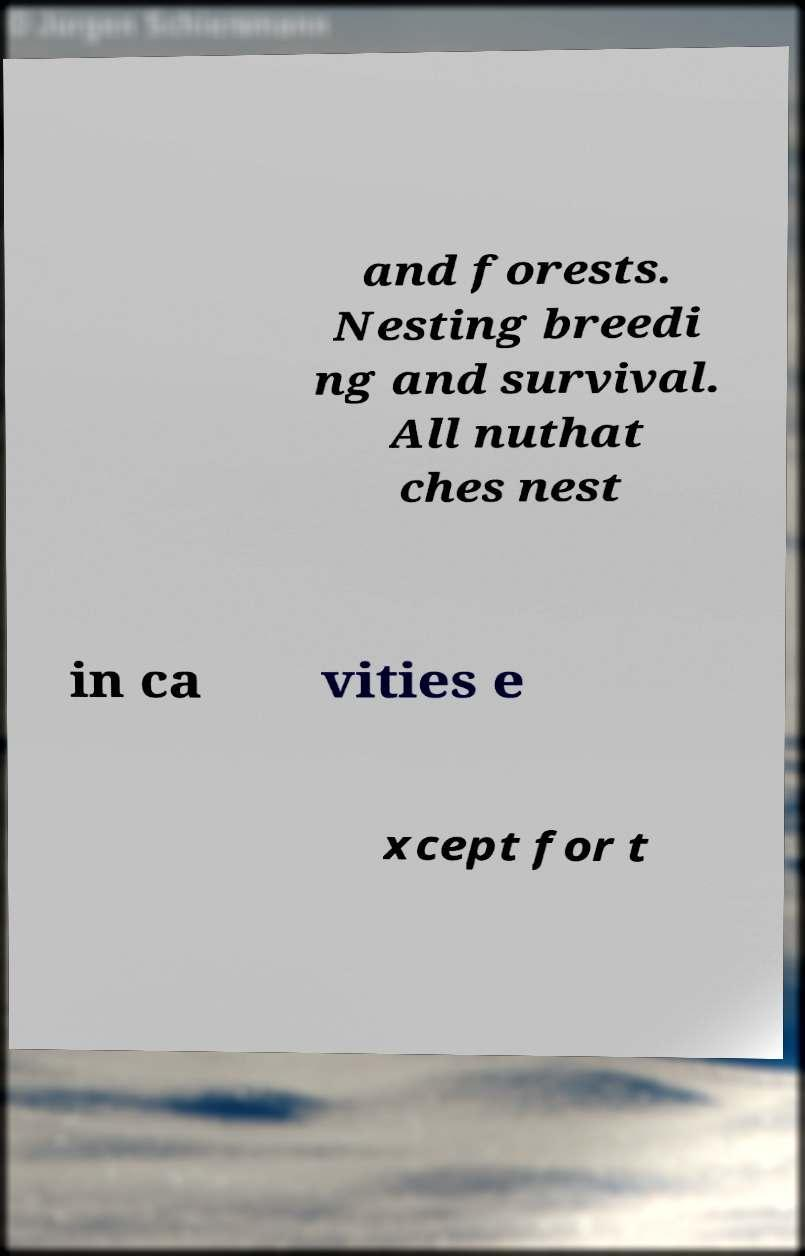I need the written content from this picture converted into text. Can you do that? and forests. Nesting breedi ng and survival. All nuthat ches nest in ca vities e xcept for t 